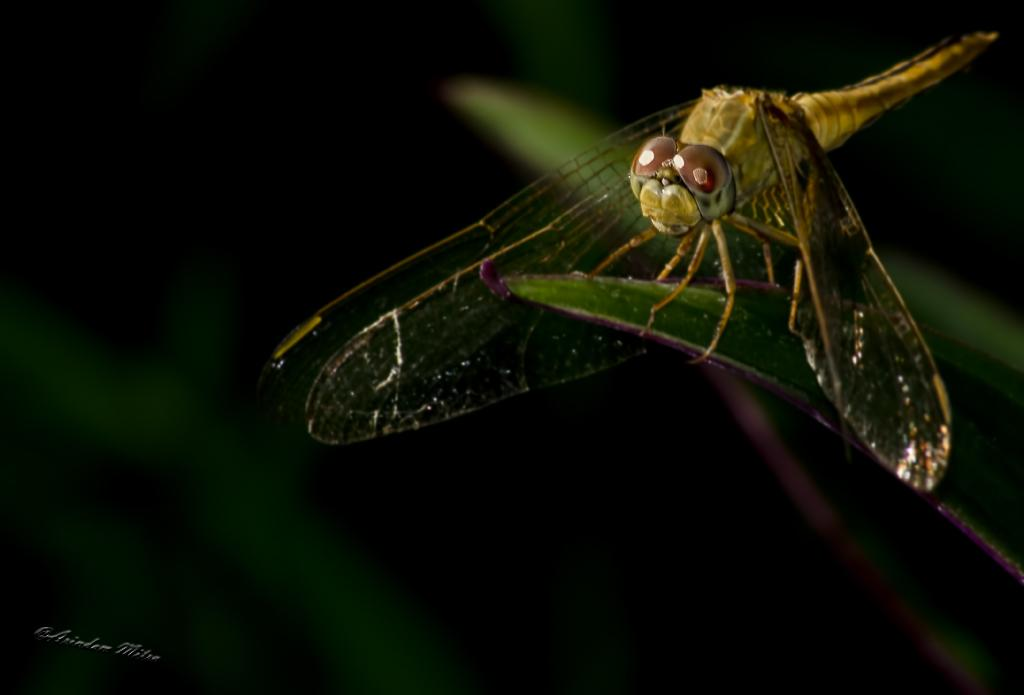What insect is present in the image? There is a dragonfly in the image. Where is the dragonfly located? The dragonfly is on a green leaf. Is there any text or marking in the image? Yes, there is a watermark in the bottom left-hand side of the image. What type of caption is written under the dragonfly in the image? There is no caption written under the dragonfly in the image. What is the dragonfly looking at in the image? The facts provided do not indicate what the dragonfly is looking at, so we cannot definitively answer this question. 